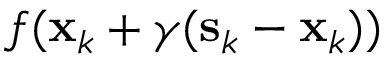Convert formula to latex. <formula><loc_0><loc_0><loc_500><loc_500>f ( x _ { k } + \gamma ( s _ { k } - x _ { k } ) )</formula> 